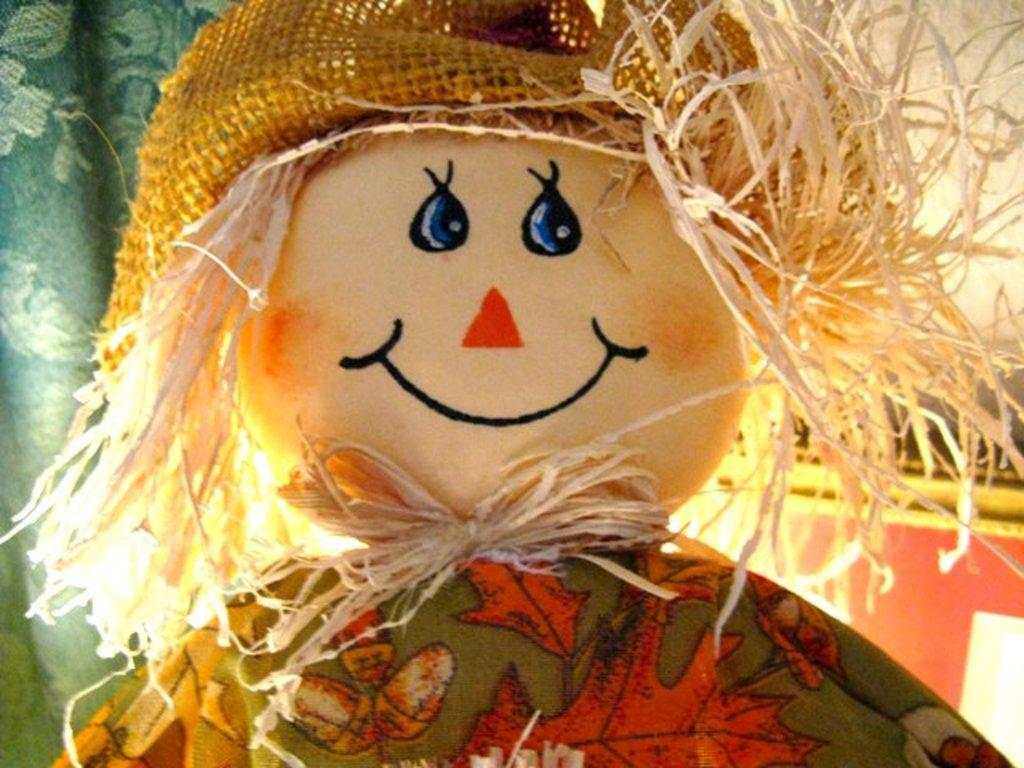What object can be seen in the image? There is a toy in the image. What is the appearance of the toy? The toy has a colorful dress and a net hat. What color is the cloth in the background? The cloth in the background is green. What other object can be seen in the background? There is a board in the background. What type of scent can be detected from the toy in the image? There is no mention of a scent in the image, so it cannot be determined from the image. 